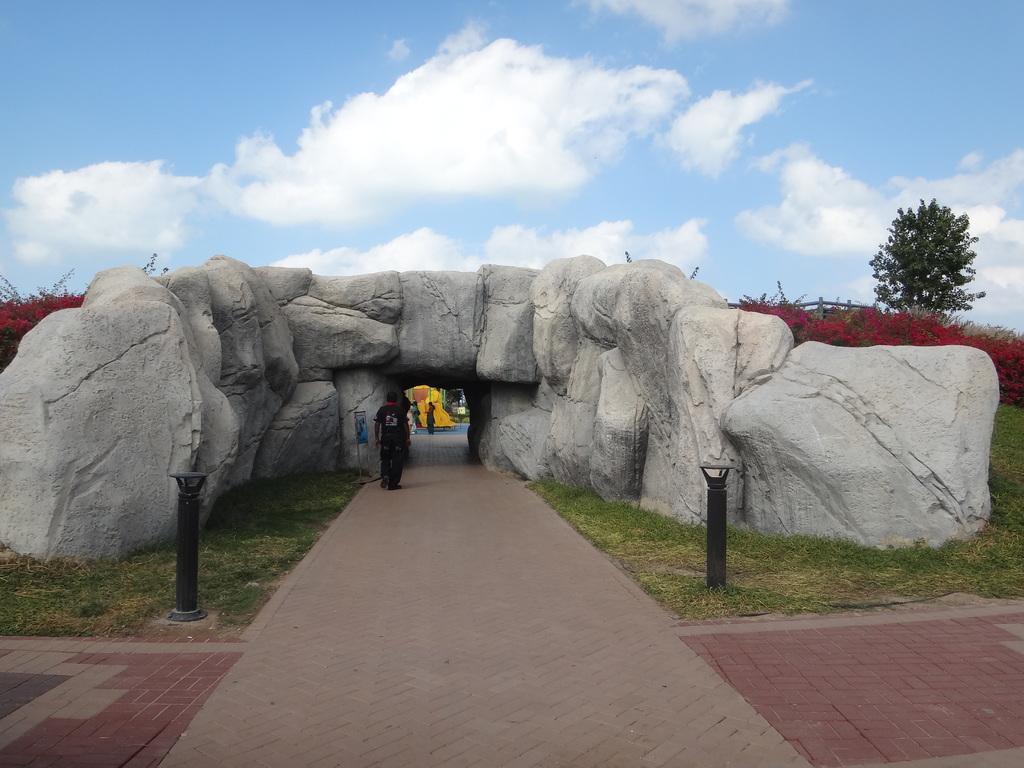How would you summarize this image in a sentence or two? In this picture we can see some people standing on a path, rocks, trees, poles and in the background we can see the sky with clouds. 